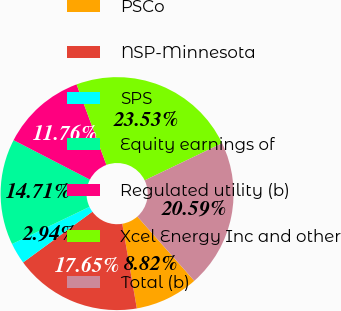<chart> <loc_0><loc_0><loc_500><loc_500><pie_chart><fcel>PSCo<fcel>NSP-Minnesota<fcel>SPS<fcel>Equity earnings of<fcel>Regulated utility (b)<fcel>Xcel Energy Inc and other<fcel>Total (b)<nl><fcel>8.82%<fcel>17.65%<fcel>2.94%<fcel>14.71%<fcel>11.76%<fcel>23.53%<fcel>20.59%<nl></chart> 